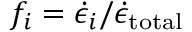Convert formula to latex. <formula><loc_0><loc_0><loc_500><loc_500>f _ { i } = \dot { \epsilon } _ { i } / \dot { \epsilon } _ { t o t a l }</formula> 